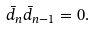<formula> <loc_0><loc_0><loc_500><loc_500>\bar { d } _ { n } \bar { d } _ { n - 1 } = 0 .</formula> 